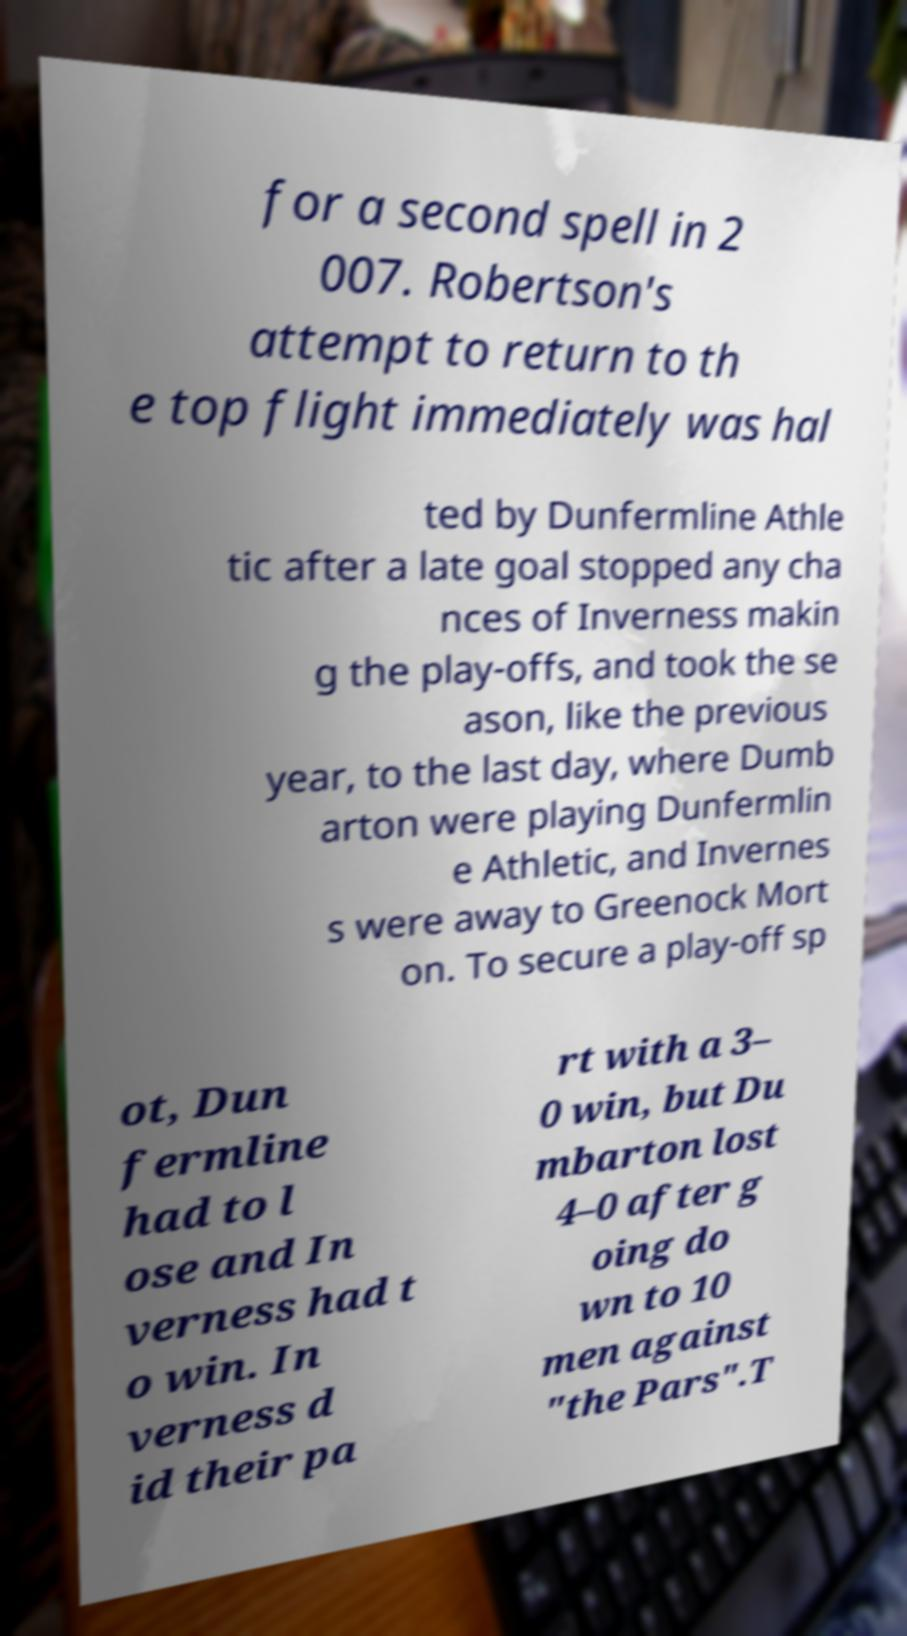What messages or text are displayed in this image? I need them in a readable, typed format. for a second spell in 2 007. Robertson's attempt to return to th e top flight immediately was hal ted by Dunfermline Athle tic after a late goal stopped any cha nces of Inverness makin g the play-offs, and took the se ason, like the previous year, to the last day, where Dumb arton were playing Dunfermlin e Athletic, and Invernes s were away to Greenock Mort on. To secure a play-off sp ot, Dun fermline had to l ose and In verness had t o win. In verness d id their pa rt with a 3– 0 win, but Du mbarton lost 4–0 after g oing do wn to 10 men against "the Pars".T 